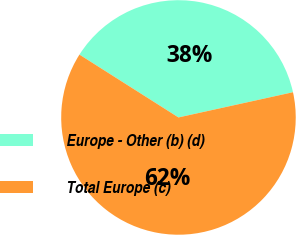<chart> <loc_0><loc_0><loc_500><loc_500><pie_chart><fcel>Europe - Other (b) (d)<fcel>Total Europe (c)<nl><fcel>37.55%<fcel>62.45%<nl></chart> 